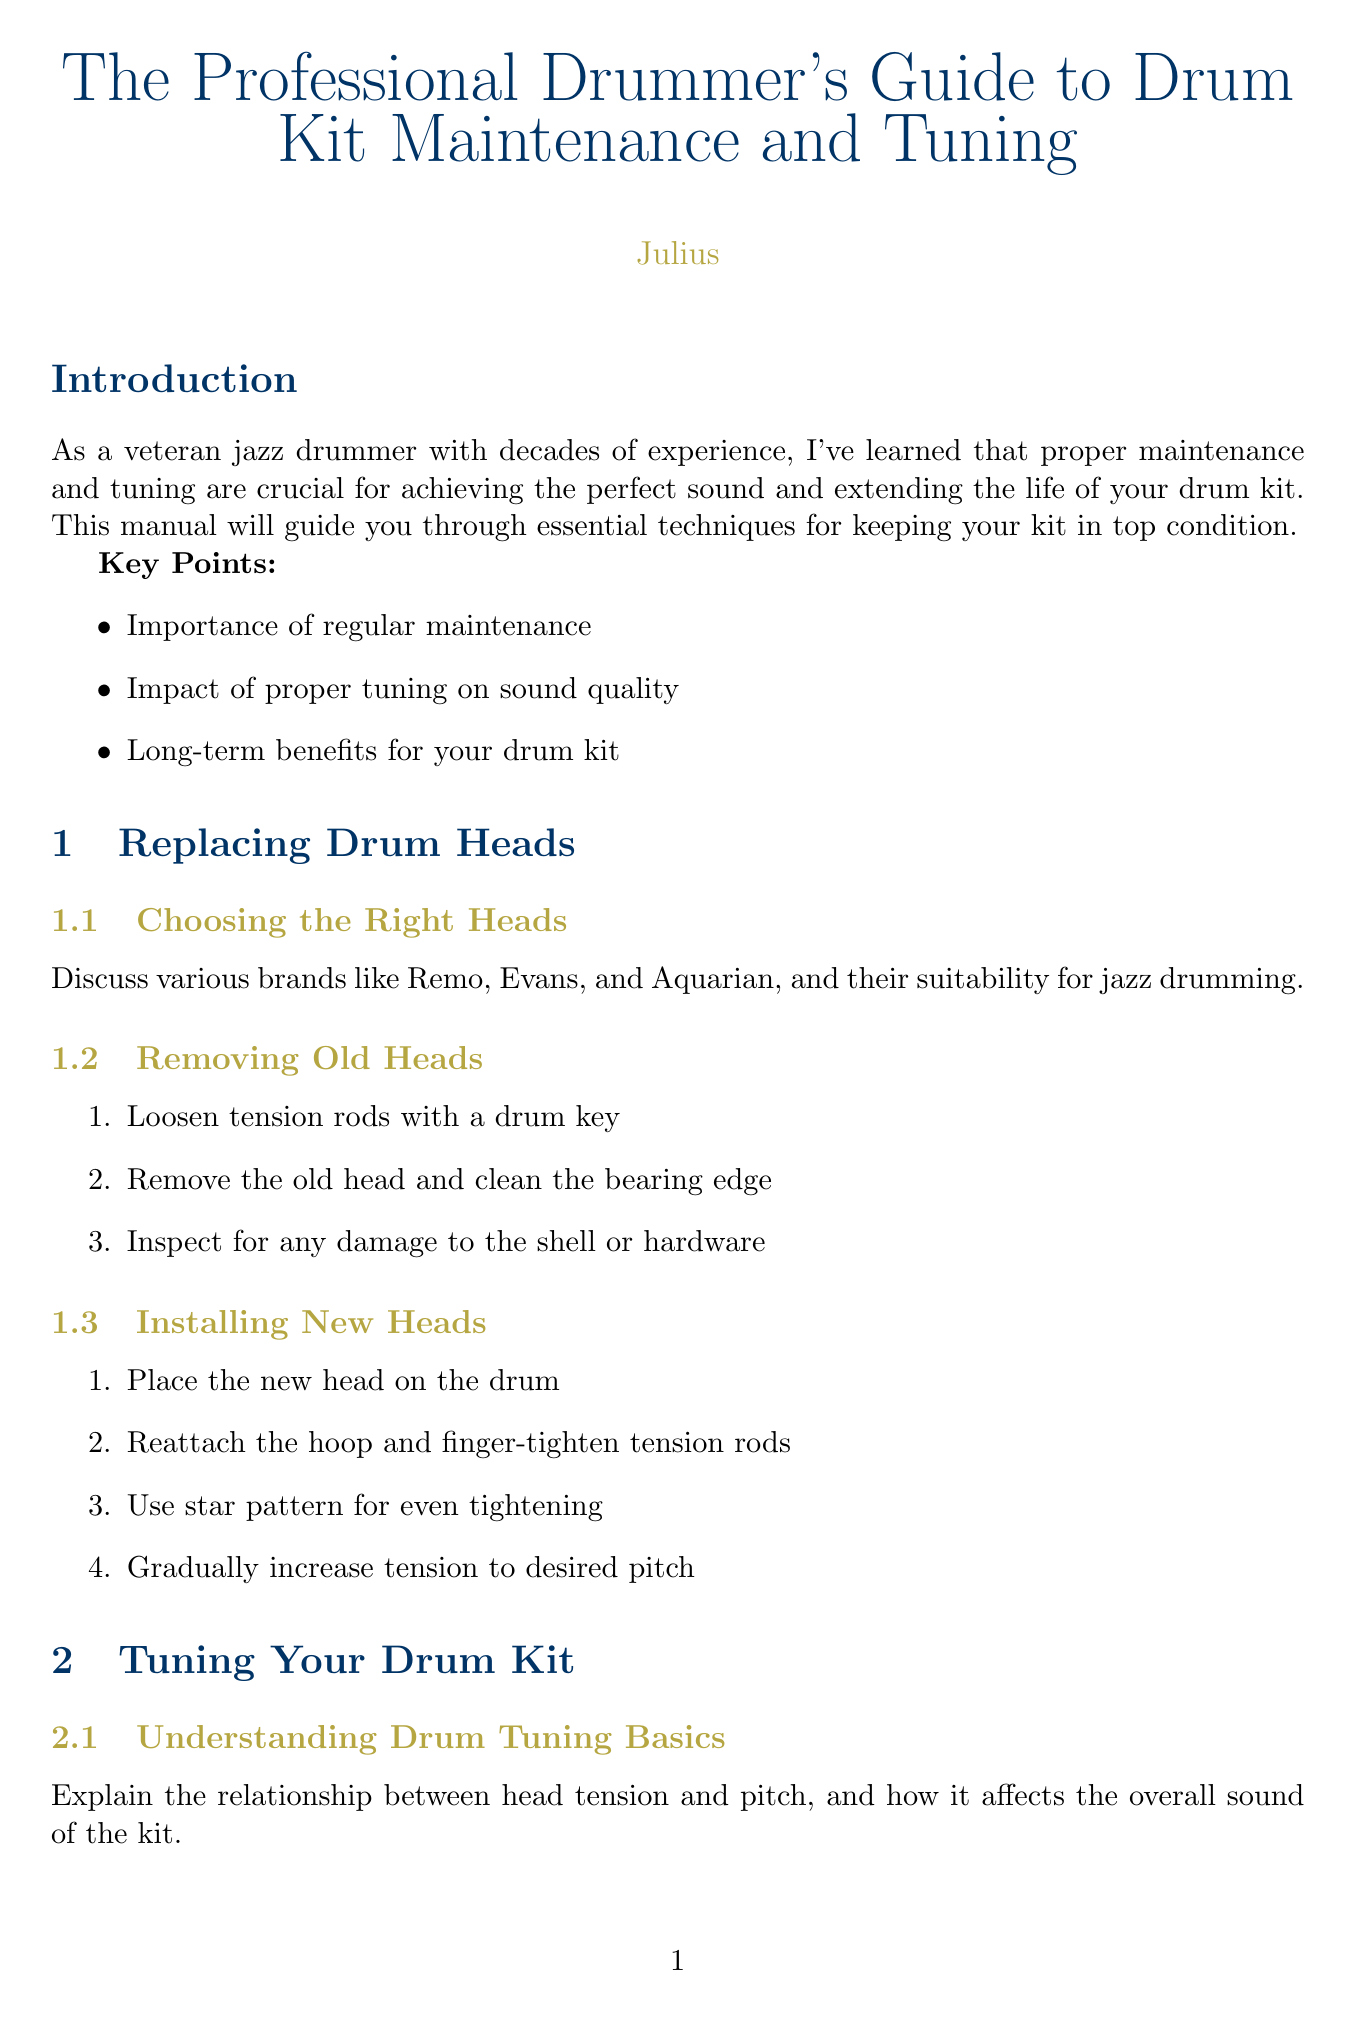What is the title of the manual? The title is explicitly stated at the beginning of the document.
Answer: The Professional Drummer's Guide to Drum Kit Maintenance and Tuning What brand names are mentioned for drum heads? The document lists specific brands suitable for jazz drumming in the relevant section.
Answer: Remo, Evans, Aquarian How many steps are there for removing old heads? The number of steps is counted in the provided list of actions for that section.
Answer: 3 What is a recommended cleaning product for cymbals? The document specifies a product for regular maintenance in the relevant section.
Answer: Zildjian Cymbal Cleaning Polish Which tool is recommended for precise tension measurement? The document lists tools in the tuning section that are useful for specific purposes.
Answer: DrumDial What should be used to prevent keyholing on cymbals? The document explains techniques related to maintaining the integrity of cymbal mounts.
Answer: Nylon sleeves How many recommended final tips are listed? The document states a specific number of tips at the conclusion.
Answer: 3 What is suggested for storing cymbals? The document provides specific recommendations on how to properly store cymbals.
Answer: Store cymbals vertically when not in use 